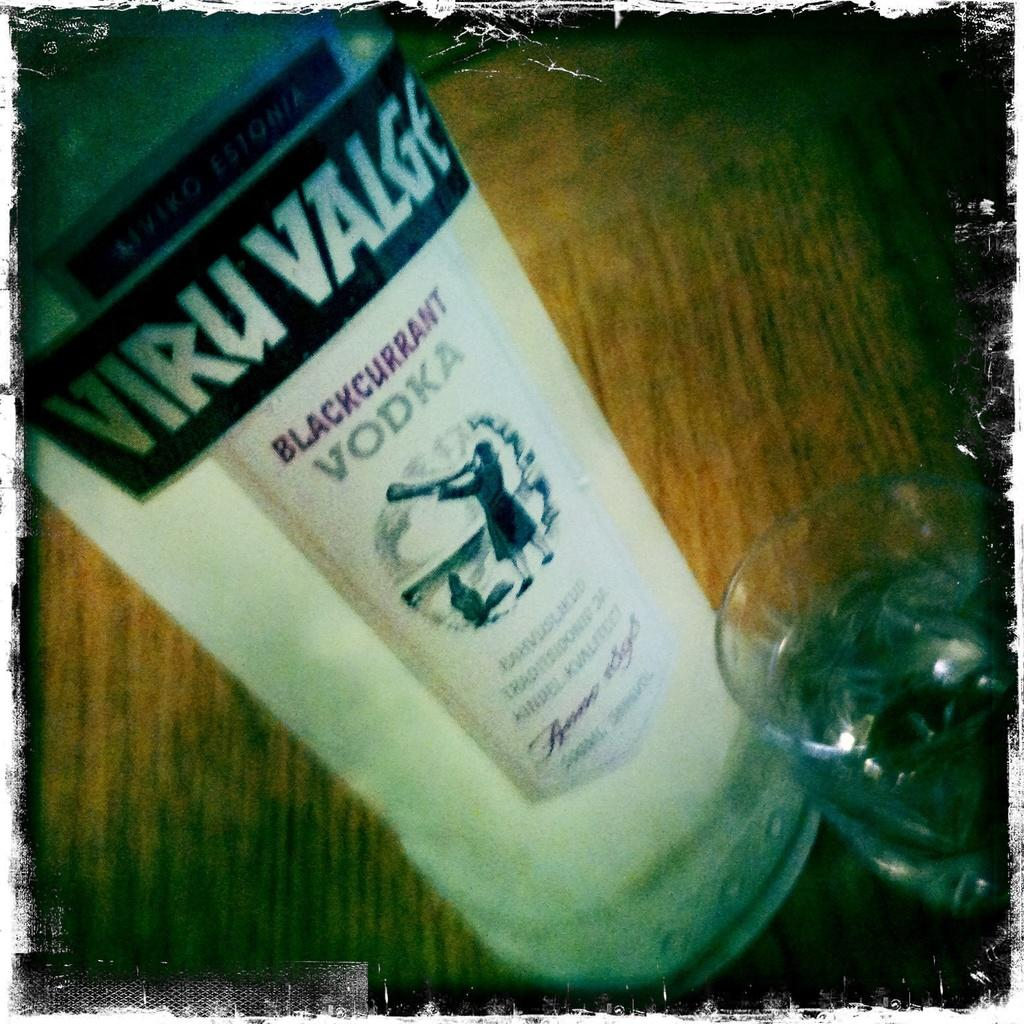<image>
Relay a brief, clear account of the picture shown. A bottle of vodka shows a woman blowing into a horn on its label. 